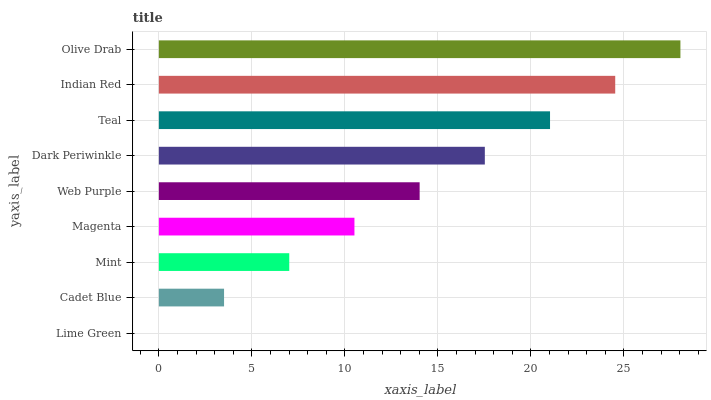Is Lime Green the minimum?
Answer yes or no. Yes. Is Olive Drab the maximum?
Answer yes or no. Yes. Is Cadet Blue the minimum?
Answer yes or no. No. Is Cadet Blue the maximum?
Answer yes or no. No. Is Cadet Blue greater than Lime Green?
Answer yes or no. Yes. Is Lime Green less than Cadet Blue?
Answer yes or no. Yes. Is Lime Green greater than Cadet Blue?
Answer yes or no. No. Is Cadet Blue less than Lime Green?
Answer yes or no. No. Is Web Purple the high median?
Answer yes or no. Yes. Is Web Purple the low median?
Answer yes or no. Yes. Is Teal the high median?
Answer yes or no. No. Is Magenta the low median?
Answer yes or no. No. 